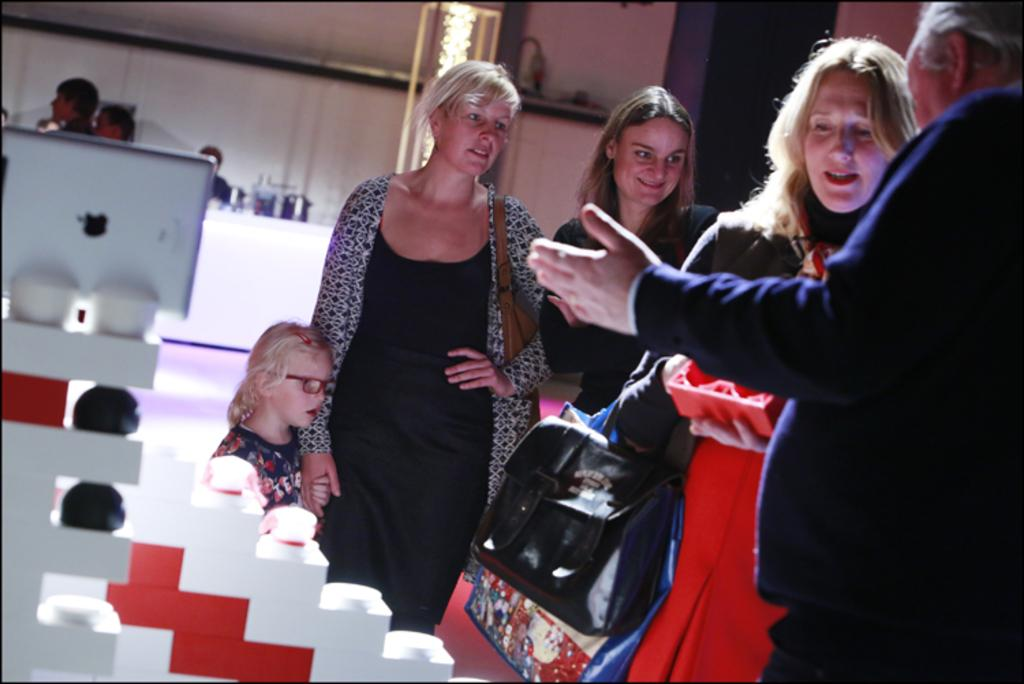How many people are in the image? There is a group of people in the image. Can you describe the clothing or accessories of any of the women in the image? One woman is wearing a bag, and another woman is carrying bags. What type of architectural features can be seen in the image? There is a wall and a pillar in the image. What else is present in the image besides the people and architectural features? There are some objects in the image. Is there any snow visible in the image? There is no snow present in the image. Can you see any planes flying in the image? There are no planes visible in the image. 